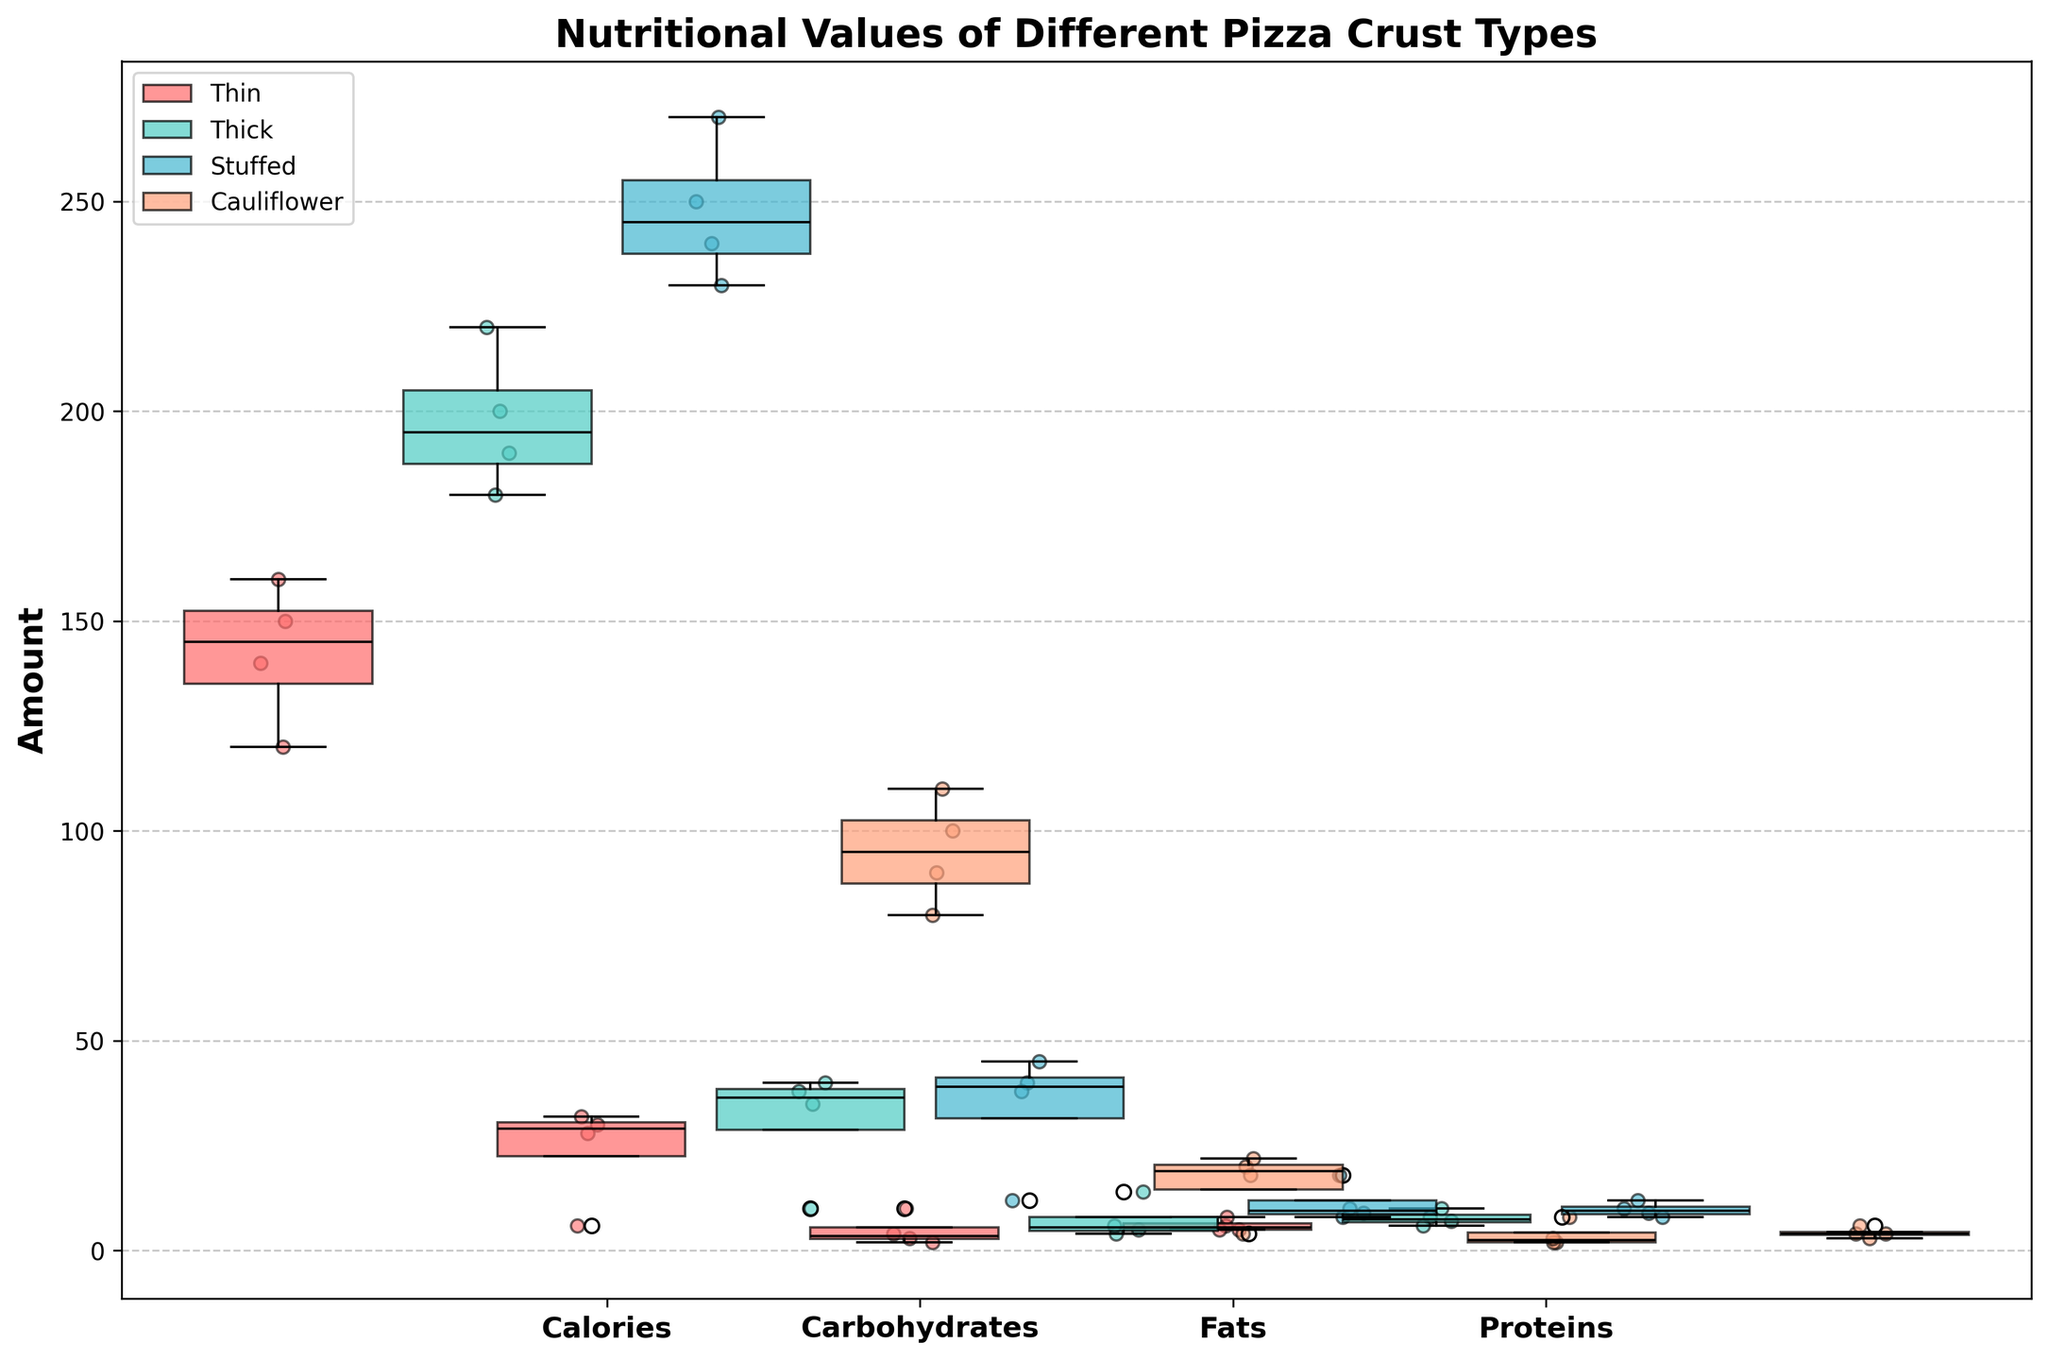What is the title of the plot? The title of the plot is displayed at the top of the figure. It provides an overview of what the plot represents.
Answer: Nutritional Values of Different Pizza Crust Types Which pizza crust type has the highest median calories? To find the pizza crust type with the highest median calories, look for the box plot with the highest median line within the 'Calories' category.
Answer: Stuffed Which flour type has the lowest scatter point in the 'Fats' category for thick crusts? To identify the lowest scatter point in the 'Fats' category for thick crusts, check the scatter points at the bottom within the 'Fats' section of the thick crust plots.
Answer: Almond Flour What is the median value for 'Proteins' in thin crust pizzas? To determine the median value, look for the black line within the box plot for 'Proteins' in the thin crust section.
Answer: 6 How does the median carbohydrates in stuffed crust compare to thin crust? Compare the median lines (black lines) in the 'Carbohydrates' category for both stuffed and thin crusts.
Answer: Higher Which pizza crust type has the least variability in protein content? The variability is determined by the length of the box plot. The shorter the box, the less variability it shows. Look for the crust type with the shortest box in the 'Proteins' category.
Answer: Cauliflower Which crust type and flour source combination has the highest protein scatter point? Find the scatter point that is the highest in the 'Proteins' category across all crust types and flour sources.
Answer: Stuffed, Almond Flour Between thin crust and cauliflower crust, which has a higher median fat content? Compare the median lines in the 'Fats' category for both thin and cauliflower crusts.
Answer: Thin Crust What can you infer about the calorie content of pizzas with almond flour? Observe the box plot and scatter points for almond flour across all pizza crust types and describe the general trends.
Answer: Generally lower 